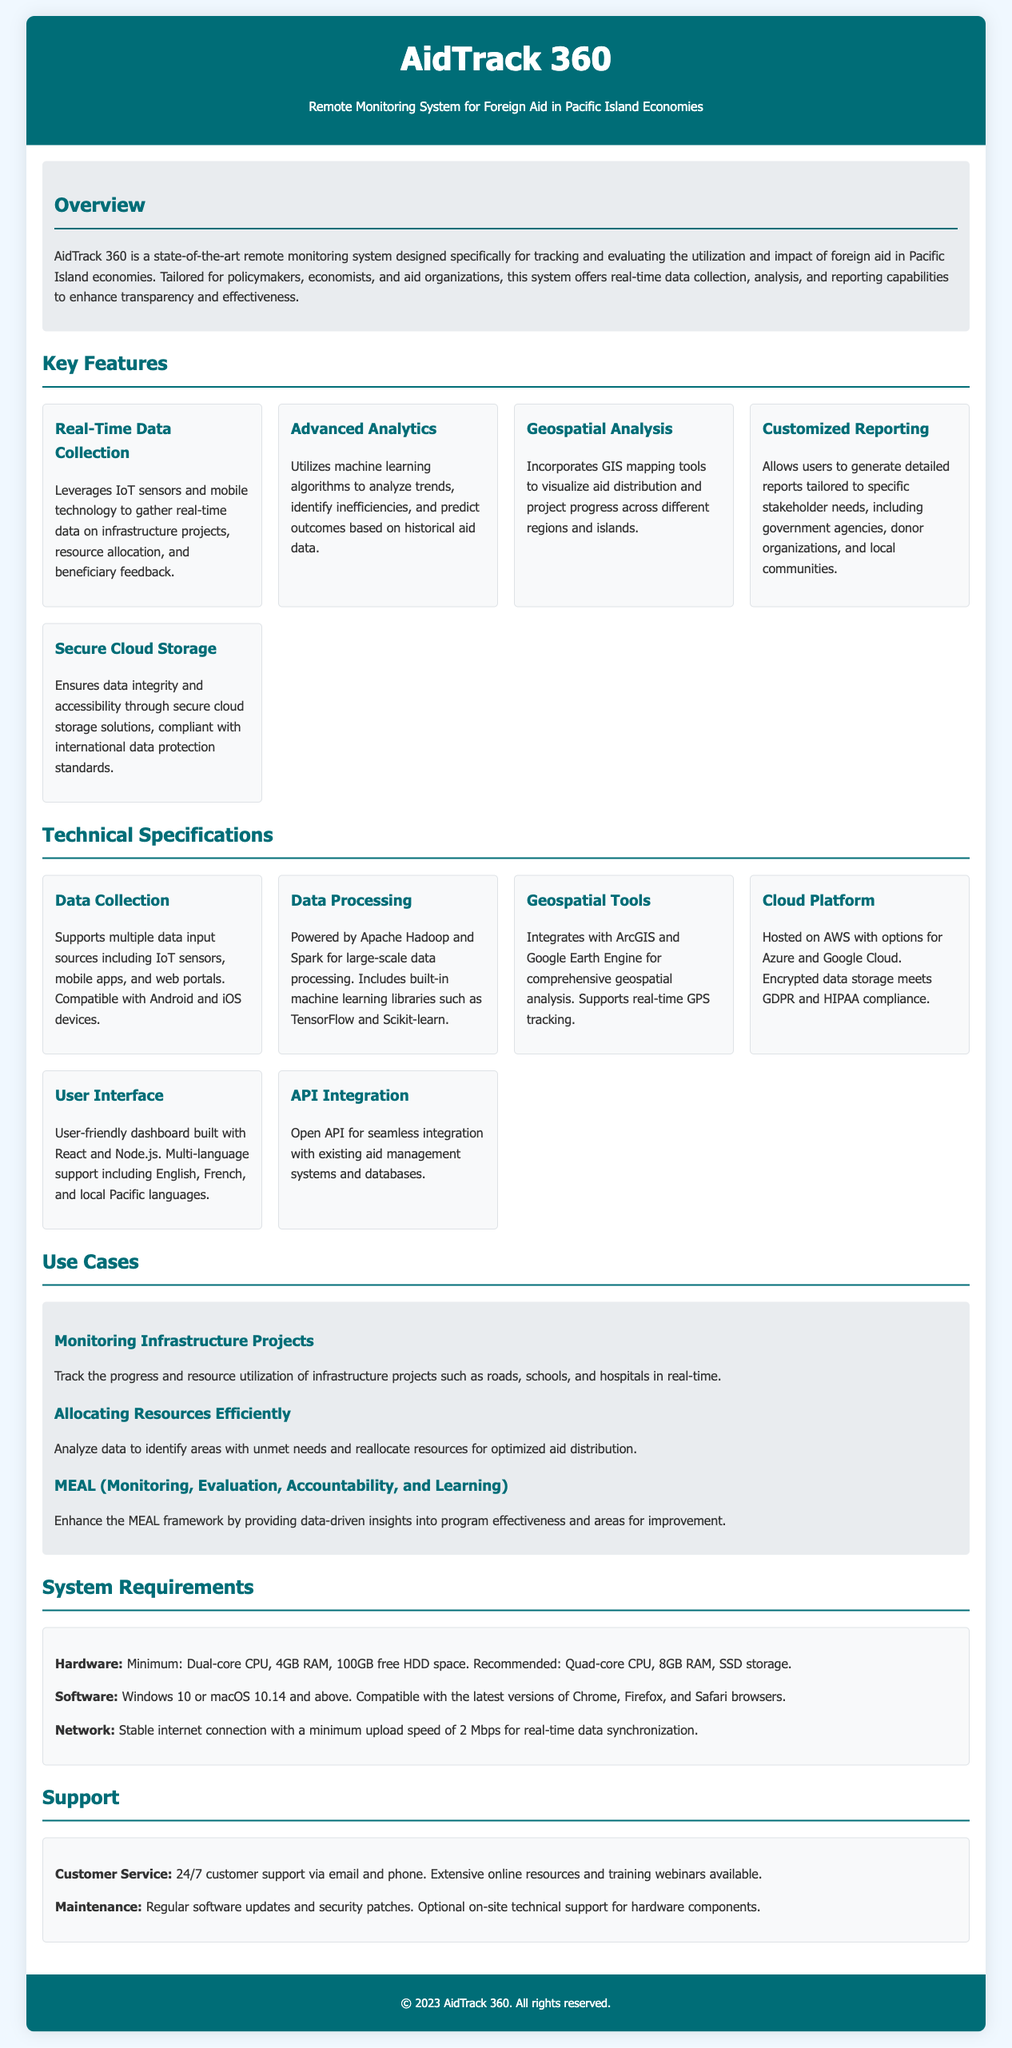What is the name of the product? The product is titled "AidTrack 360" in the document.
Answer: AidTrack 360 What is the purpose of AidTrack 360? The overview section describes it as a remote monitoring system for tracking and evaluating foreign aid utilization.
Answer: Remote monitoring system for foreign aid How many key features are listed? The document lists five key features under the Key Features section.
Answer: Five What technology does the system utilize for large-scale data processing? The technical specifications state that it is powered by Apache Hadoop and Spark.
Answer: Apache Hadoop and Spark Which geospatial tools are integrated with the system? The document specifies integration with ArcGIS and Google Earth Engine.
Answer: ArcGIS and Google Earth Engine What is the minimum hardware requirement for the system? The system requirements specify a minimum dual-core CPU, 4GB RAM, and 100GB free HDD space.
Answer: Dual-core CPU, 4GB RAM, 100GB HDD What type of customer support is available? The support section states that 24/7 customer support is provided via email and phone.
Answer: 24/7 customer support What feature of the product allows for real-time data collection? The real-time data collection feature leverages IoT sensors and mobile technology.
Answer: IoT sensors and mobile technology What is the primary audience for AidTrack 360? The overview mentions policymakers, economists, and aid organizations as the primary audience.
Answer: Policymakers, economists, and aid organizations 